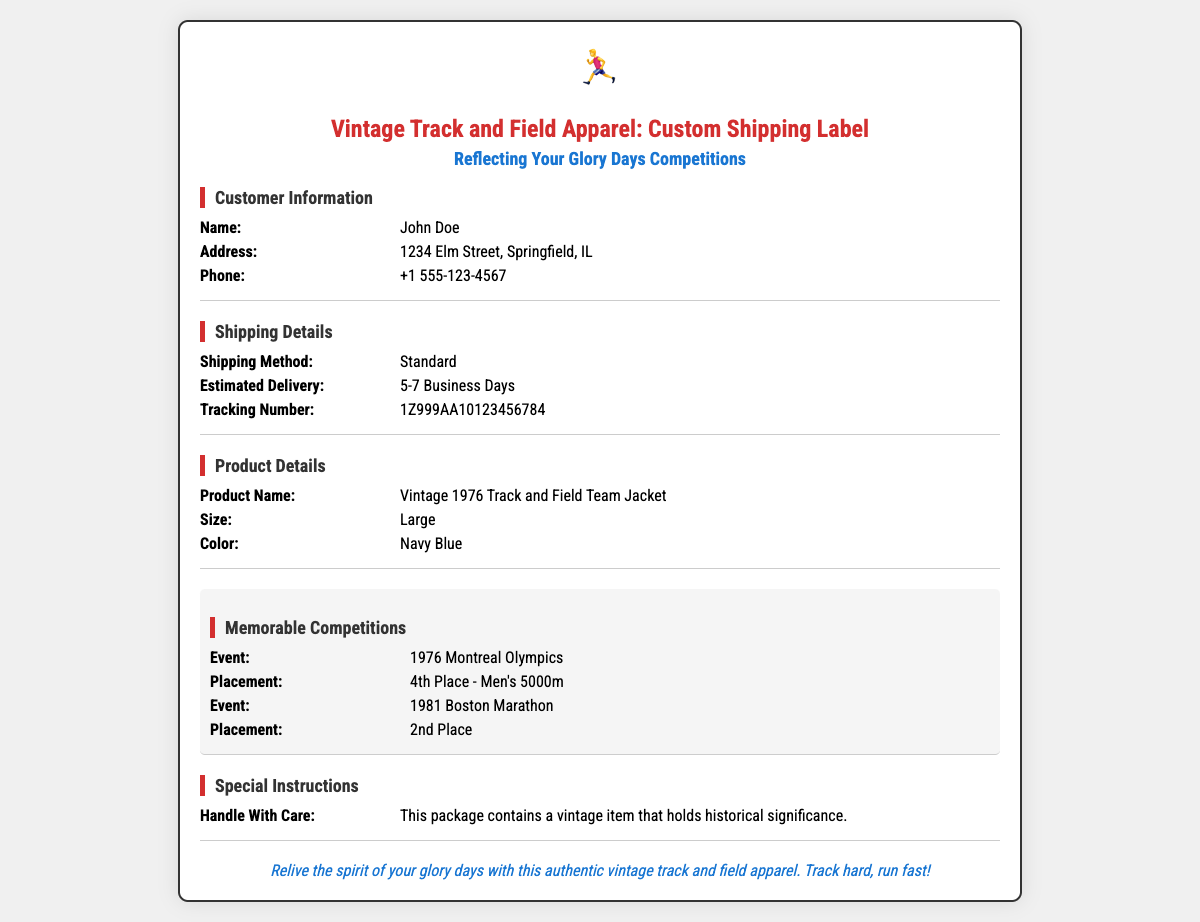What is the name of the customer? The customer's name is listed in the customer information section of the document.
Answer: John Doe What is the shipping method? The shipping method is specified in the shipping details section of the document.
Answer: Standard What is the estimated delivery time? The estimated delivery time is found in the shipping details section of the document.
Answer: 5-7 Business Days What was the placement of the customer in the 1976 Montreal Olympics? The placement is noted in the memorable competitions section of the document.
Answer: 4th Place - Men's 5000m What color is the product? The color of the product is mentioned in the product details section of the document.
Answer: Navy Blue Which marathon did the customer place 2nd in? The specific event is highlighted in the memorable competitions section of the document.
Answer: 1981 Boston Marathon What special instruction is given for handling the package? The handling instruction is specified in the special instructions section of the document.
Answer: This package contains a vintage item that holds historical significance Who is the target audience for this shipping label? The document is tailored for individuals who have nostalgic ties to past athletic competitions.
Answer: Retired track athletes What type of apparel is being shipped? The type of item being shipped is listed in the product details section of the document.
Answer: Vintage 1976 Track and Field Team Jacket 